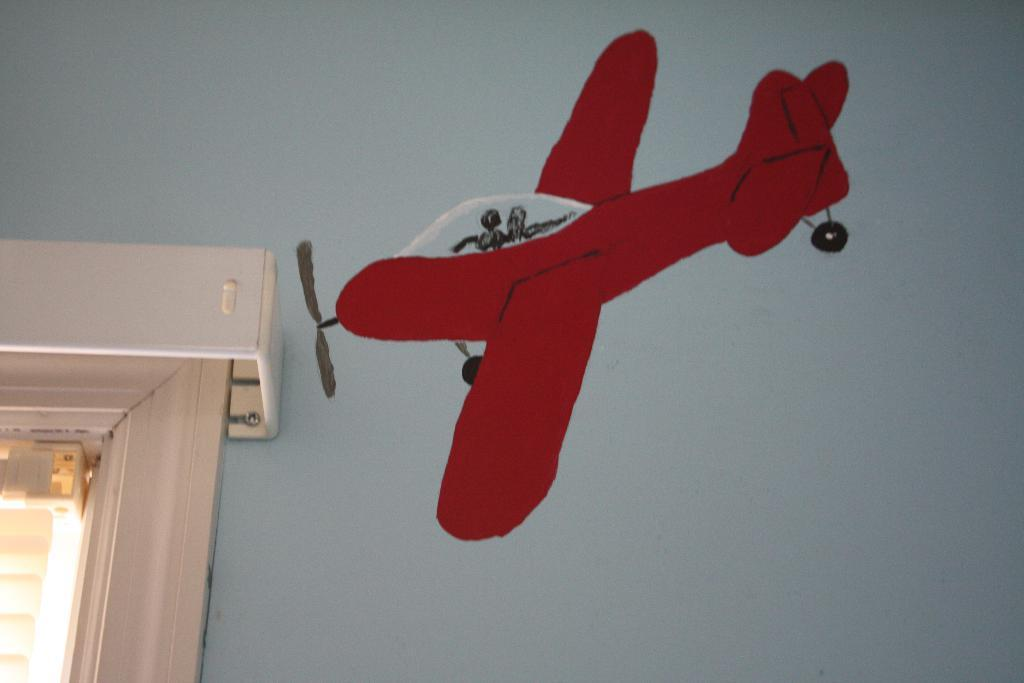What is present on the wall in the image? There is a painting of flying on the wall. Can you describe the painting? The painting depicts flying, but no specific subject or context is mentioned. What else can be seen in the image? There is a window in the image. What type of secretary is sitting next to the window in the image? There is no secretary present in the image; it only features a wall with a painting and a window. 